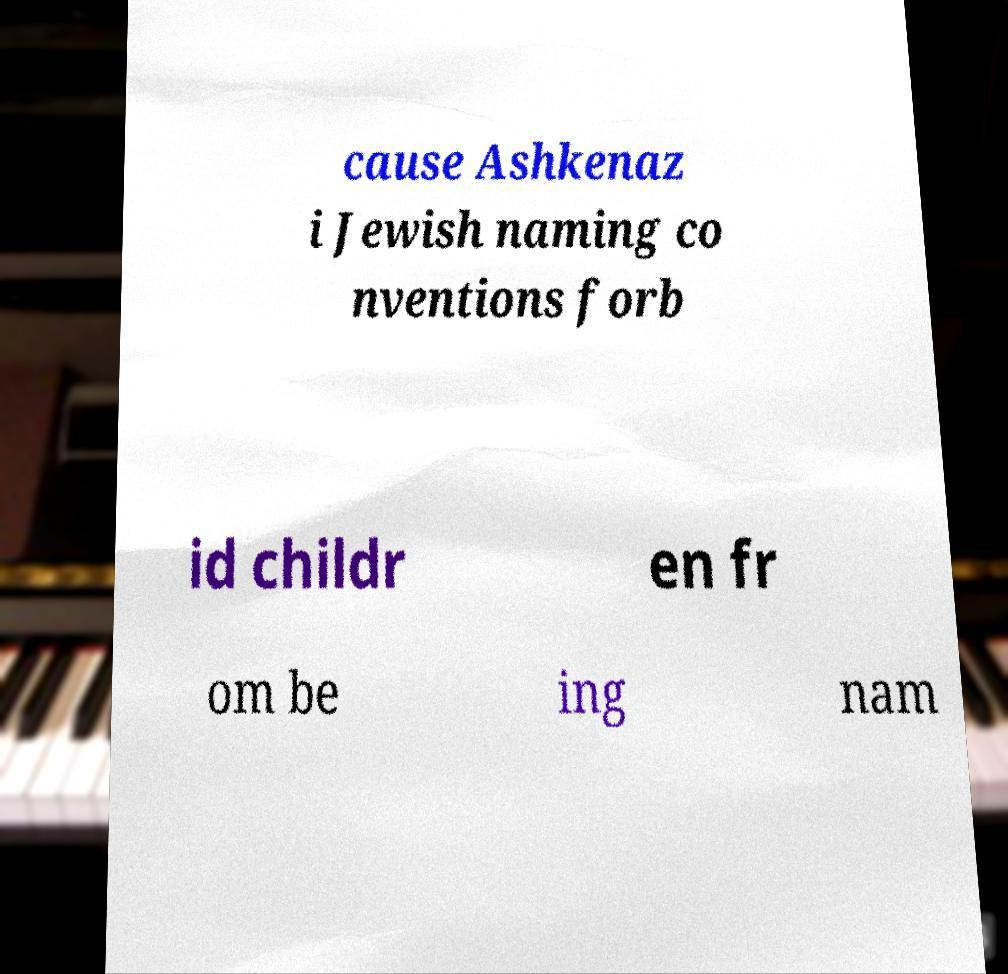I need the written content from this picture converted into text. Can you do that? cause Ashkenaz i Jewish naming co nventions forb id childr en fr om be ing nam 